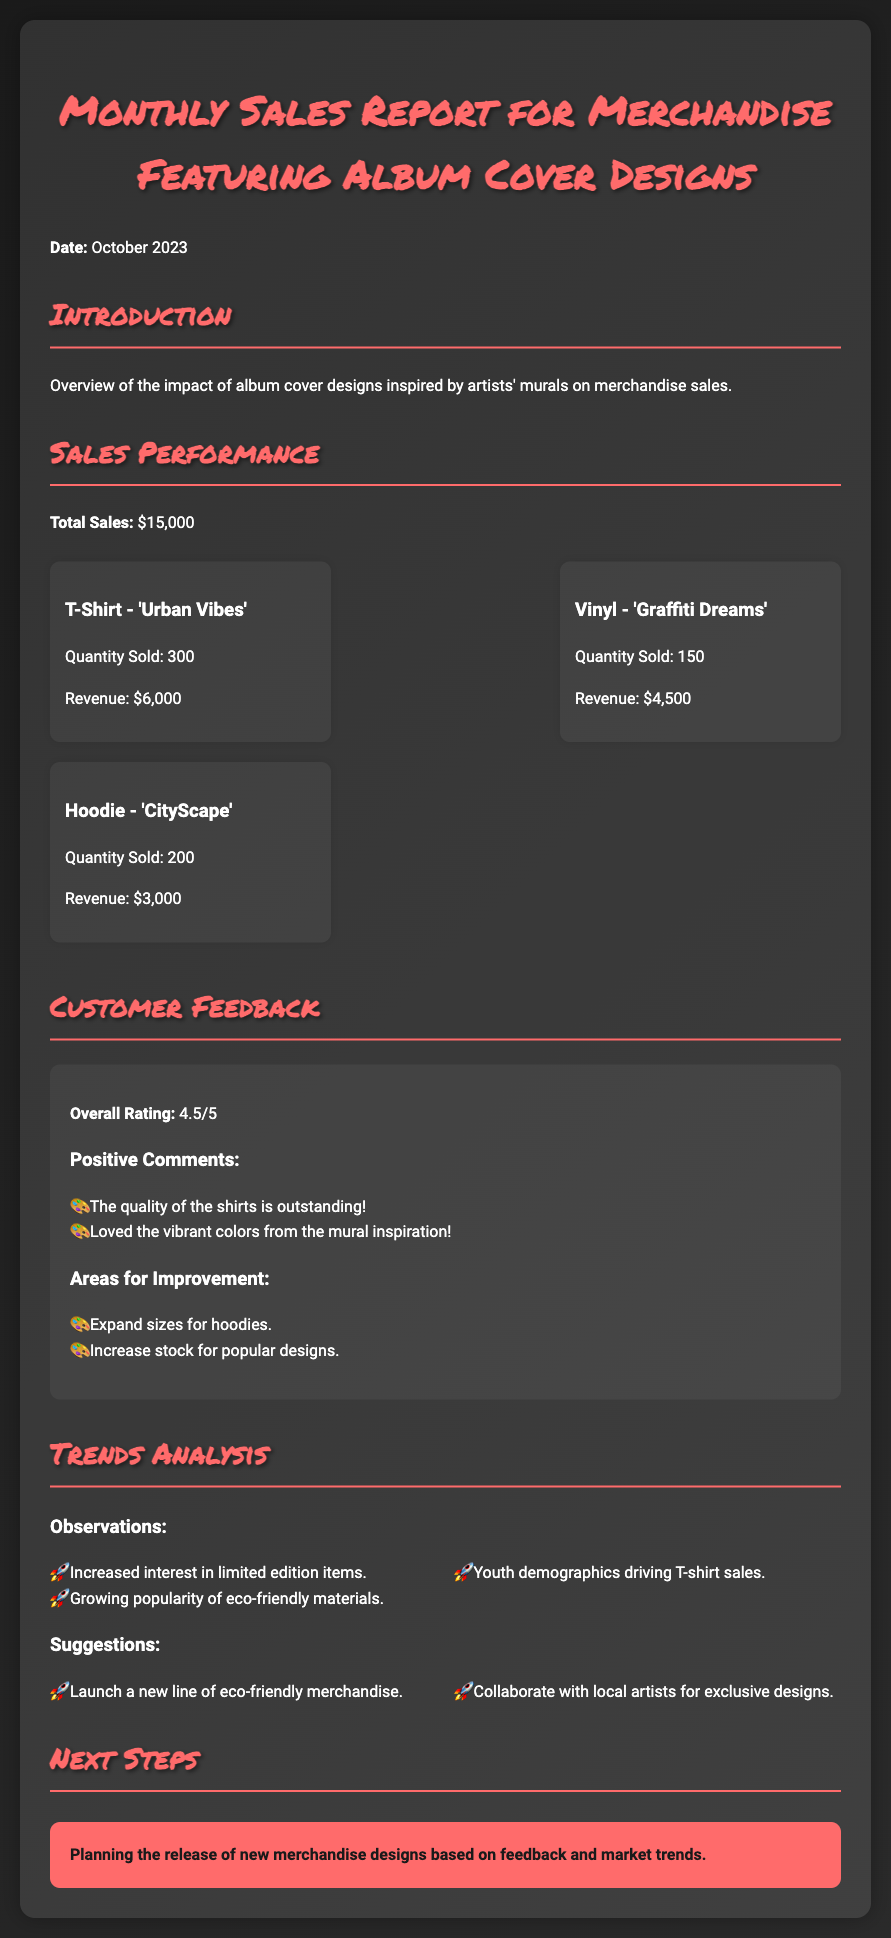What is the total sales amount? The total sales amount is stated in the document under "Sales Performance" as $15,000.
Answer: $15,000 How many T-Shirts were sold? The quantity sold for T-Shirts is listed under "Sales Performance" as 300.
Answer: 300 What is the overall customer feedback rating? The overall rating is found in the "Customer Feedback" section as 4.5 out of 5.
Answer: 4.5/5 What type of merchandise is driving the sales according to youth? The document mentions that T-shirts are driving sales among youth demographics, indicated in the "Trends Analysis."
Answer: T-shirts What is one suggested area for improvement? The document lists an area for improvement in the "Areas for Improvement" section as expanding sizes for hoodies.
Answer: Expand sizes for hoodies How much revenue did the Vinyl 'Graffiti Dreams' generate? The revenue from the Vinyl is documented under "Sales Performance" as $4,500.
Answer: $4,500 What is one observation mentioned in the Trends Analysis? The Trends Analysis section includes observations, one of which is the increased interest in limited edition items.
Answer: Increased interest in limited edition items What is the main focus of the next steps mentioned in the document? The next steps focus on planning the release of new merchandise designs based on feedback and market trends.
Answer: New merchandise designs What product generated the least revenue? The revenue generated by the hoodie 'CityScape' is the least at $3,000, as stated in the "Sales Performance" section.
Answer: Hoodie - 'CityScape' 